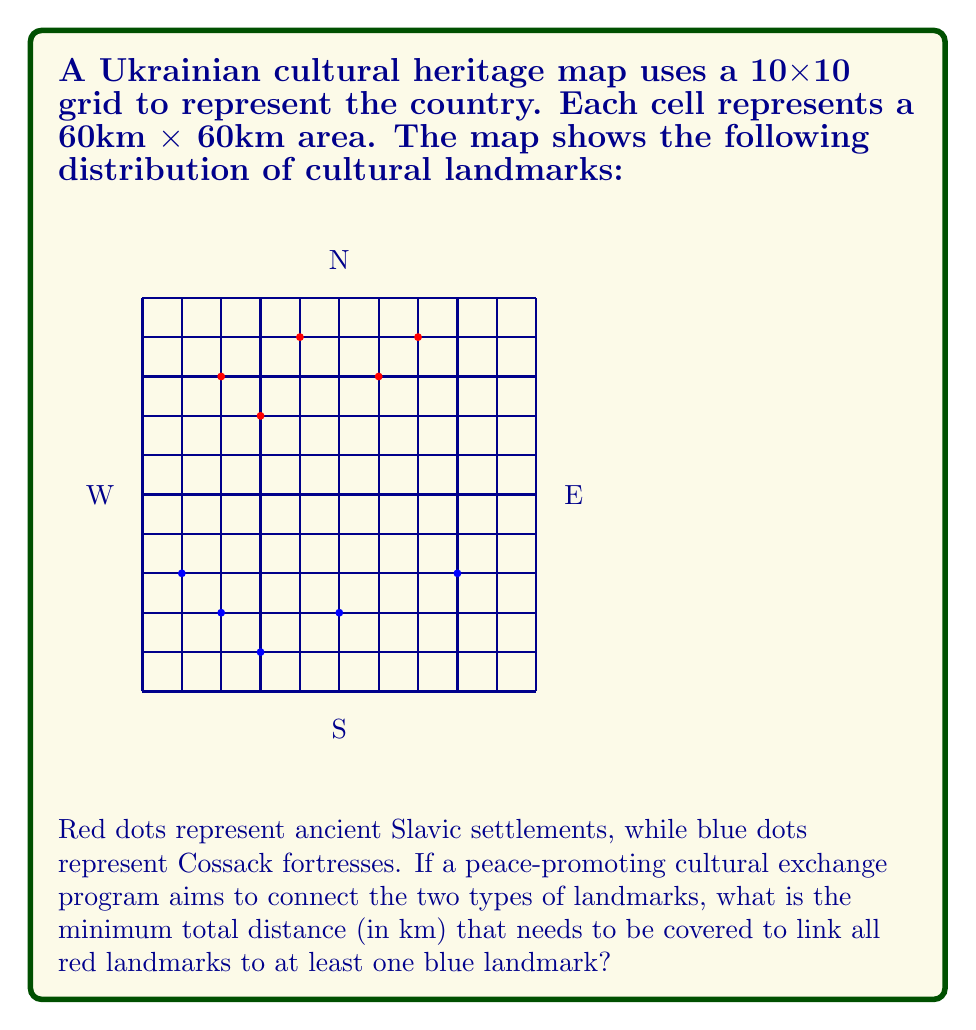Provide a solution to this math problem. Let's approach this step-by-step:

1) First, we need to identify the coordinates of each landmark:

   Red (Slavic settlements): (2,8), (3,7), (4,9), (6,8), (7,9)
   Blue (Cossack fortresses): (1,3), (2,2), (3,1), (5,2), (8,3)

2) For each red landmark, we need to find the closest blue landmark. We can use the Manhattan distance (sum of horizontal and vertical distances) as we're working on a grid.

3) Let's calculate the distances:

   (2,8) to (5,2): |2-5| + |8-2| = 3 + 6 = 9
   (3,7) to (5,2): |3-5| + |7-2| = 2 + 5 = 7
   (4,9) to (5,2): |4-5| + |9-2| = 1 + 7 = 8
   (6,8) to (5,2): |6-5| + |8-2| = 1 + 6 = 7
   (7,9) to (8,3): |7-8| + |9-3| = 1 + 6 = 7

4) The minimum distance for each red landmark to a blue landmark is:
   7 + 7 + 7 + 7 + 8 = 36 grid units

5) Each grid unit represents 60km, so the total distance is:
   36 * 60 = 2160 km

Therefore, the minimum total distance to connect all red landmarks to at least one blue landmark is 2160 km.
Answer: 2160 km 